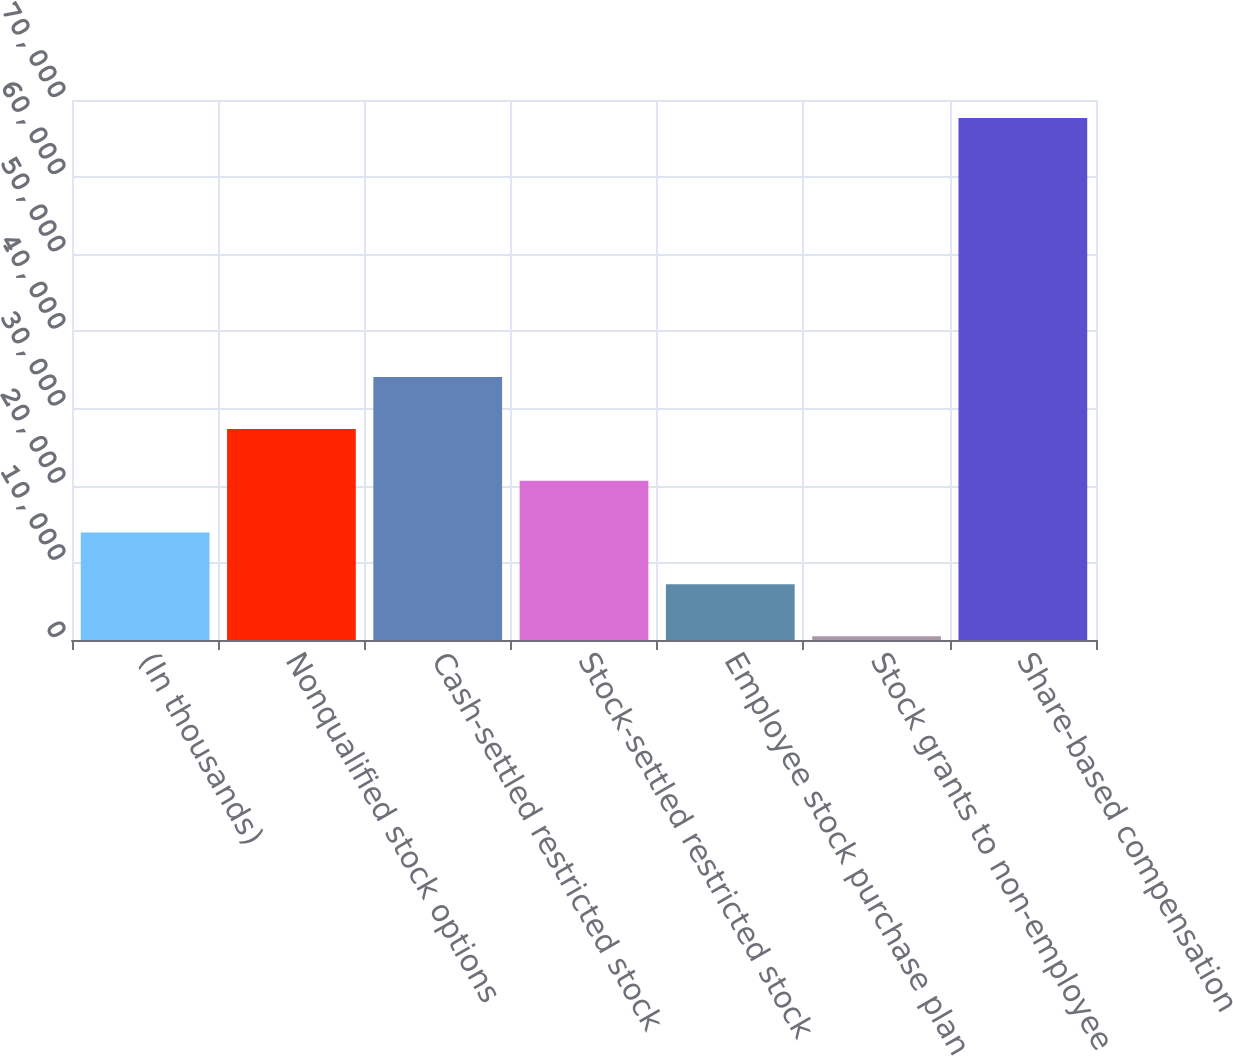Convert chart to OTSL. <chart><loc_0><loc_0><loc_500><loc_500><bar_chart><fcel>(In thousands)<fcel>Nonqualified stock options<fcel>Cash-settled restricted stock<fcel>Stock-settled restricted stock<fcel>Employee stock purchase plan<fcel>Stock grants to non-employee<fcel>Share-based compensation<nl><fcel>13934<fcel>27368<fcel>34085<fcel>20651<fcel>7217<fcel>500<fcel>67670<nl></chart> 